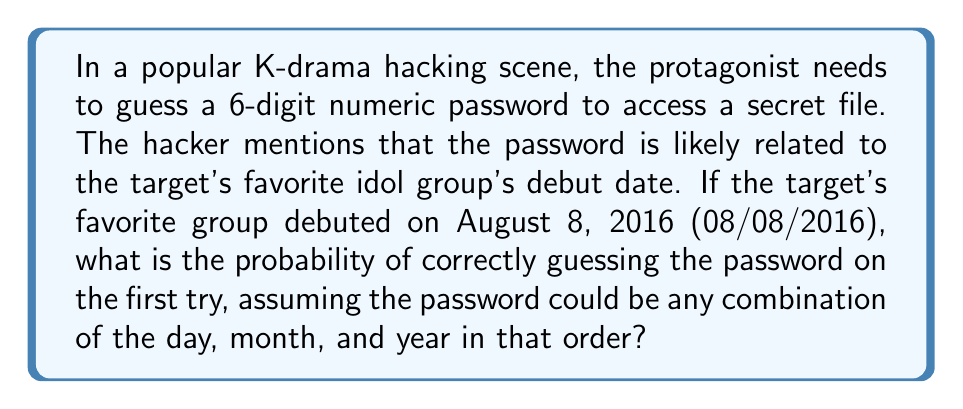Show me your answer to this math problem. Let's approach this step-by-step:

1) The debut date is 08/08/2016, which gives us three components to work with:
   - Day: 08
   - Month: 08
   - Year: 2016

2) For a 6-digit password, we need to consider all possible combinations of these numbers:
   080816, 081608, 160808, 080216, 021608, 160208

3) There are 6 possible combinations in total.

4) The probability of guessing the correct password is the number of favorable outcomes divided by the total number of possible outcomes.

5) In this case:
   - Favorable outcomes: 1 (the correct combination)
   - Total possible outcomes: $10^6$ (all possible 6-digit numbers)

6) The probability is thus:

   $$P(\text{correct guess}) = \frac{\text{favorable outcomes}}{\text{total outcomes}} = \frac{1}{10^6} = \frac{1}{1,000,000} = 0.000001$$

Therefore, the probability of guessing the correct password on the first try is $\frac{1}{1,000,000}$ or 0.0001%.
Answer: $\frac{1}{1,000,000}$ 